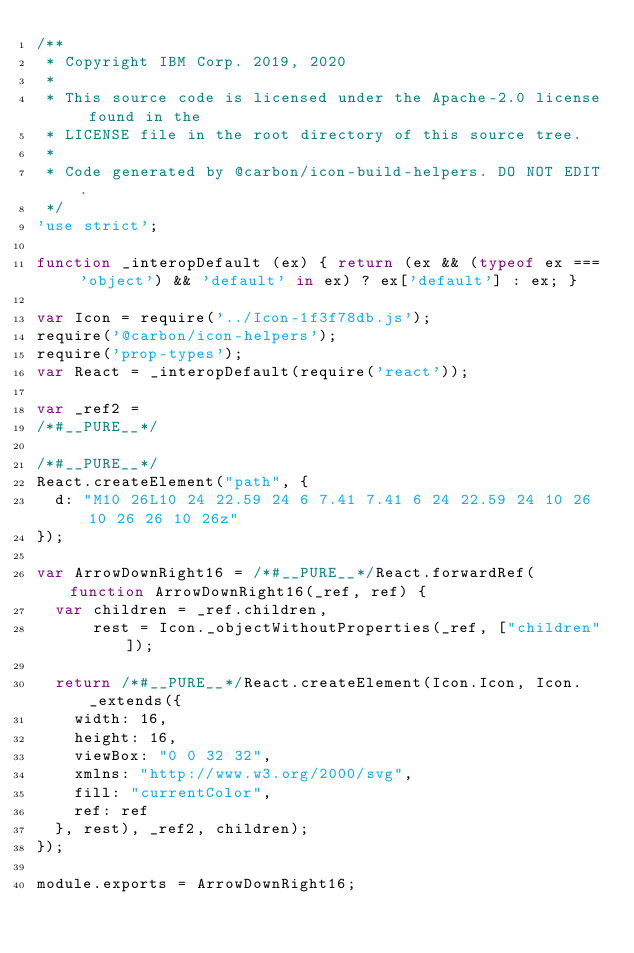Convert code to text. <code><loc_0><loc_0><loc_500><loc_500><_JavaScript_>/**
 * Copyright IBM Corp. 2019, 2020
 *
 * This source code is licensed under the Apache-2.0 license found in the
 * LICENSE file in the root directory of this source tree.
 *
 * Code generated by @carbon/icon-build-helpers. DO NOT EDIT.
 */
'use strict';

function _interopDefault (ex) { return (ex && (typeof ex === 'object') && 'default' in ex) ? ex['default'] : ex; }

var Icon = require('../Icon-1f3f78db.js');
require('@carbon/icon-helpers');
require('prop-types');
var React = _interopDefault(require('react'));

var _ref2 =
/*#__PURE__*/

/*#__PURE__*/
React.createElement("path", {
  d: "M10 26L10 24 22.59 24 6 7.41 7.41 6 24 22.59 24 10 26 10 26 26 10 26z"
});

var ArrowDownRight16 = /*#__PURE__*/React.forwardRef(function ArrowDownRight16(_ref, ref) {
  var children = _ref.children,
      rest = Icon._objectWithoutProperties(_ref, ["children"]);

  return /*#__PURE__*/React.createElement(Icon.Icon, Icon._extends({
    width: 16,
    height: 16,
    viewBox: "0 0 32 32",
    xmlns: "http://www.w3.org/2000/svg",
    fill: "currentColor",
    ref: ref
  }, rest), _ref2, children);
});

module.exports = ArrowDownRight16;
</code> 